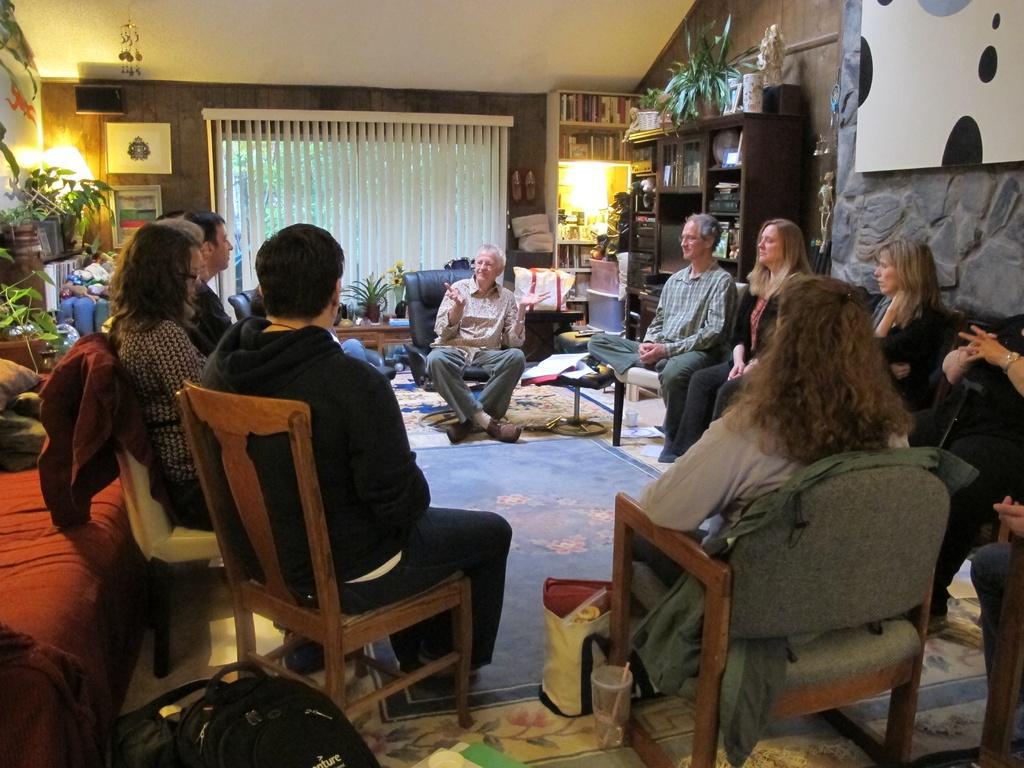Describe this image in one or two sentences. There are many people sitting on chair. There are bags, cups, carpet is on the floor. There is a red sofa. Also there are some plants. In the background there is a curtain with window, cupboards with books> on the cupboard there are some items kept. On the wall there is a photo frame. Inside the cupboard there are books. And there are lights in the corner. On the wall there is a shoe. 